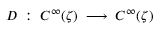<formula> <loc_0><loc_0><loc_500><loc_500>D \, \colon \, C ^ { \infty } ( \zeta ) \, \longrightarrow \, C ^ { \infty } ( \zeta )</formula> 